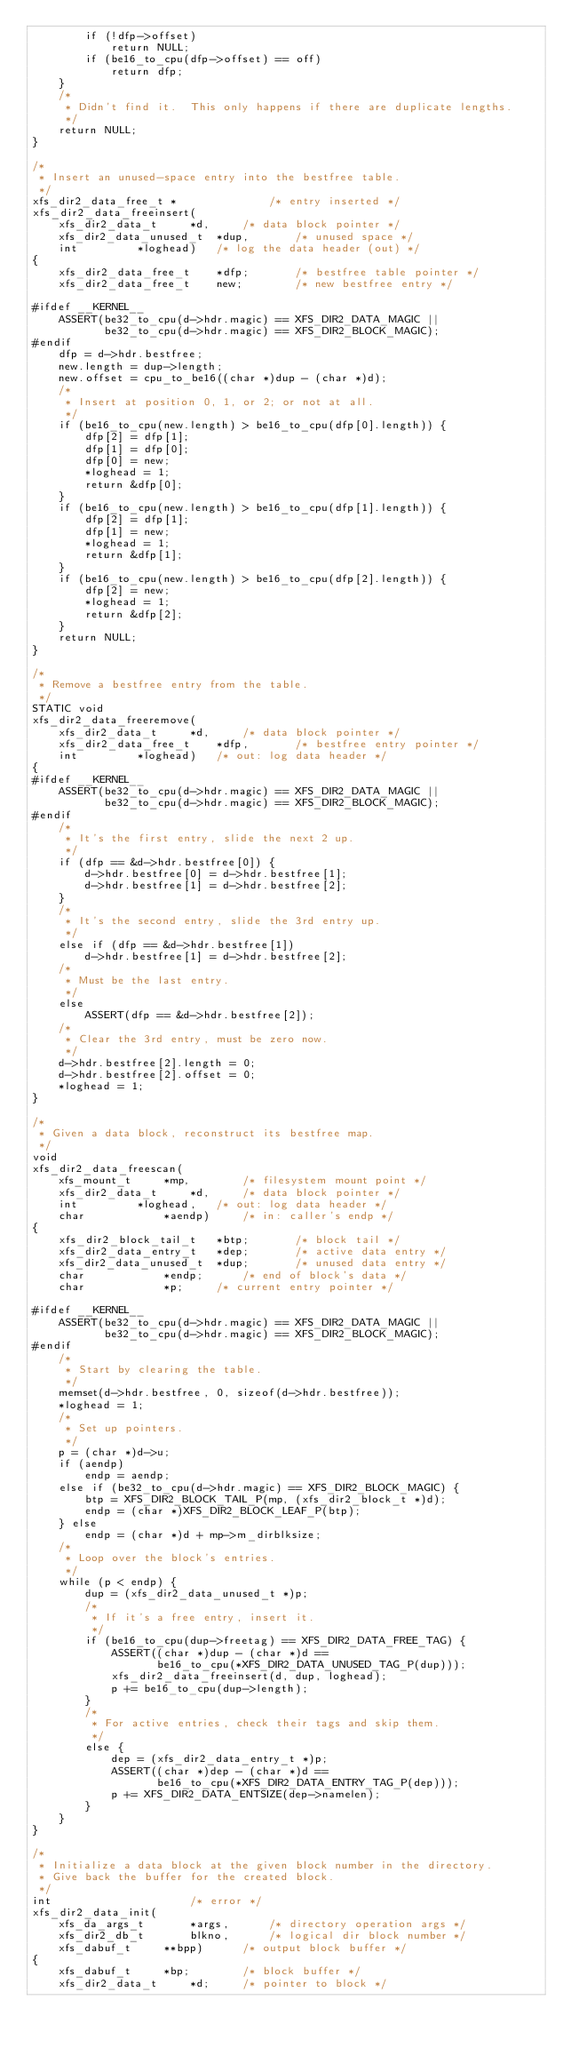Convert code to text. <code><loc_0><loc_0><loc_500><loc_500><_C_>		if (!dfp->offset)
			return NULL;
		if (be16_to_cpu(dfp->offset) == off)
			return dfp;
	}
	/*
	 * Didn't find it.  This only happens if there are duplicate lengths.
	 */
	return NULL;
}

/*
 * Insert an unused-space entry into the bestfree table.
 */
xfs_dir2_data_free_t *				/* entry inserted */
xfs_dir2_data_freeinsert(
	xfs_dir2_data_t		*d,		/* data block pointer */
	xfs_dir2_data_unused_t	*dup,		/* unused space */
	int			*loghead)	/* log the data header (out) */
{
	xfs_dir2_data_free_t	*dfp;		/* bestfree table pointer */
	xfs_dir2_data_free_t	new;		/* new bestfree entry */

#ifdef __KERNEL__
	ASSERT(be32_to_cpu(d->hdr.magic) == XFS_DIR2_DATA_MAGIC ||
	       be32_to_cpu(d->hdr.magic) == XFS_DIR2_BLOCK_MAGIC);
#endif
	dfp = d->hdr.bestfree;
	new.length = dup->length;
	new.offset = cpu_to_be16((char *)dup - (char *)d);
	/*
	 * Insert at position 0, 1, or 2; or not at all.
	 */
	if (be16_to_cpu(new.length) > be16_to_cpu(dfp[0].length)) {
		dfp[2] = dfp[1];
		dfp[1] = dfp[0];
		dfp[0] = new;
		*loghead = 1;
		return &dfp[0];
	}
	if (be16_to_cpu(new.length) > be16_to_cpu(dfp[1].length)) {
		dfp[2] = dfp[1];
		dfp[1] = new;
		*loghead = 1;
		return &dfp[1];
	}
	if (be16_to_cpu(new.length) > be16_to_cpu(dfp[2].length)) {
		dfp[2] = new;
		*loghead = 1;
		return &dfp[2];
	}
	return NULL;
}

/*
 * Remove a bestfree entry from the table.
 */
STATIC void
xfs_dir2_data_freeremove(
	xfs_dir2_data_t		*d,		/* data block pointer */
	xfs_dir2_data_free_t	*dfp,		/* bestfree entry pointer */
	int			*loghead)	/* out: log data header */
{
#ifdef __KERNEL__
	ASSERT(be32_to_cpu(d->hdr.magic) == XFS_DIR2_DATA_MAGIC ||
	       be32_to_cpu(d->hdr.magic) == XFS_DIR2_BLOCK_MAGIC);
#endif
	/*
	 * It's the first entry, slide the next 2 up.
	 */
	if (dfp == &d->hdr.bestfree[0]) {
		d->hdr.bestfree[0] = d->hdr.bestfree[1];
		d->hdr.bestfree[1] = d->hdr.bestfree[2];
	}
	/*
	 * It's the second entry, slide the 3rd entry up.
	 */
	else if (dfp == &d->hdr.bestfree[1])
		d->hdr.bestfree[1] = d->hdr.bestfree[2];
	/*
	 * Must be the last entry.
	 */
	else
		ASSERT(dfp == &d->hdr.bestfree[2]);
	/*
	 * Clear the 3rd entry, must be zero now.
	 */
	d->hdr.bestfree[2].length = 0;
	d->hdr.bestfree[2].offset = 0;
	*loghead = 1;
}

/*
 * Given a data block, reconstruct its bestfree map.
 */
void
xfs_dir2_data_freescan(
	xfs_mount_t		*mp,		/* filesystem mount point */
	xfs_dir2_data_t		*d,		/* data block pointer */
	int			*loghead,	/* out: log data header */
	char			*aendp)		/* in: caller's endp */
{
	xfs_dir2_block_tail_t	*btp;		/* block tail */
	xfs_dir2_data_entry_t	*dep;		/* active data entry */
	xfs_dir2_data_unused_t	*dup;		/* unused data entry */
	char			*endp;		/* end of block's data */
	char			*p;		/* current entry pointer */

#ifdef __KERNEL__
	ASSERT(be32_to_cpu(d->hdr.magic) == XFS_DIR2_DATA_MAGIC ||
	       be32_to_cpu(d->hdr.magic) == XFS_DIR2_BLOCK_MAGIC);
#endif
	/*
	 * Start by clearing the table.
	 */
	memset(d->hdr.bestfree, 0, sizeof(d->hdr.bestfree));
	*loghead = 1;
	/*
	 * Set up pointers.
	 */
	p = (char *)d->u;
	if (aendp)
		endp = aendp;
	else if (be32_to_cpu(d->hdr.magic) == XFS_DIR2_BLOCK_MAGIC) {
		btp = XFS_DIR2_BLOCK_TAIL_P(mp, (xfs_dir2_block_t *)d);
		endp = (char *)XFS_DIR2_BLOCK_LEAF_P(btp);
	} else
		endp = (char *)d + mp->m_dirblksize;
	/*
	 * Loop over the block's entries.
	 */
	while (p < endp) {
		dup = (xfs_dir2_data_unused_t *)p;
		/*
		 * If it's a free entry, insert it.
		 */
		if (be16_to_cpu(dup->freetag) == XFS_DIR2_DATA_FREE_TAG) {
			ASSERT((char *)dup - (char *)d ==
			       be16_to_cpu(*XFS_DIR2_DATA_UNUSED_TAG_P(dup)));
			xfs_dir2_data_freeinsert(d, dup, loghead);
			p += be16_to_cpu(dup->length);
		}
		/*
		 * For active entries, check their tags and skip them.
		 */
		else {
			dep = (xfs_dir2_data_entry_t *)p;
			ASSERT((char *)dep - (char *)d ==
			       be16_to_cpu(*XFS_DIR2_DATA_ENTRY_TAG_P(dep)));
			p += XFS_DIR2_DATA_ENTSIZE(dep->namelen);
		}
	}
}

/*
 * Initialize a data block at the given block number in the directory.
 * Give back the buffer for the created block.
 */
int						/* error */
xfs_dir2_data_init(
	xfs_da_args_t		*args,		/* directory operation args */
	xfs_dir2_db_t		blkno,		/* logical dir block number */
	xfs_dabuf_t		**bpp)		/* output block buffer */
{
	xfs_dabuf_t		*bp;		/* block buffer */
	xfs_dir2_data_t		*d;		/* pointer to block */</code> 